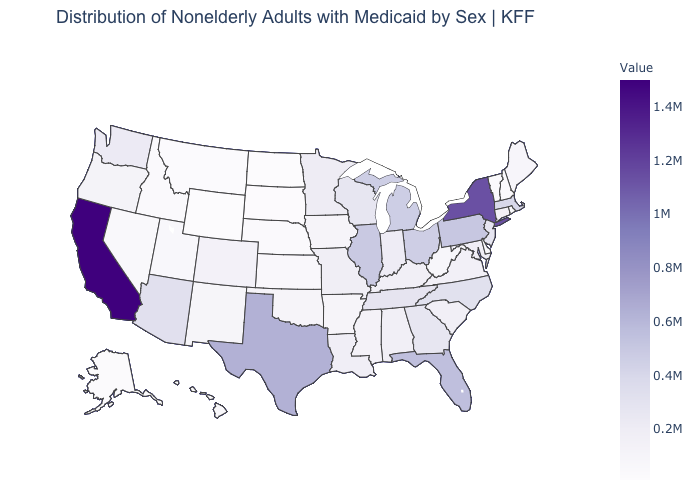Is the legend a continuous bar?
Keep it brief. Yes. Among the states that border Pennsylvania , which have the highest value?
Short answer required. New York. Is the legend a continuous bar?
Give a very brief answer. Yes. 